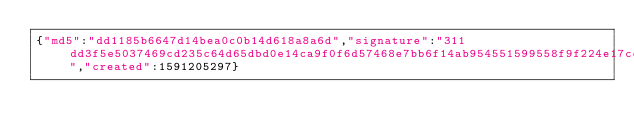<code> <loc_0><loc_0><loc_500><loc_500><_SML_>{"md5":"dd1185b6647d14bea0c0b14d618a8a6d","signature":"311dd3f5e5037469cd235c64d65dbd0e14ca9f0f6d57468e7bb6f14ab954551599558f9f224e17cc9a66d6806aed5d1bedb9481cf92b8d6d6a2f68a2f7bedd0f","created":1591205297}</code> 